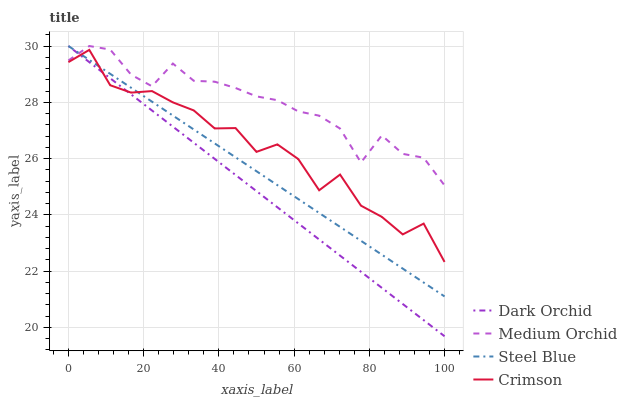Does Dark Orchid have the minimum area under the curve?
Answer yes or no. Yes. Does Medium Orchid have the maximum area under the curve?
Answer yes or no. Yes. Does Steel Blue have the minimum area under the curve?
Answer yes or no. No. Does Steel Blue have the maximum area under the curve?
Answer yes or no. No. Is Dark Orchid the smoothest?
Answer yes or no. Yes. Is Crimson the roughest?
Answer yes or no. Yes. Is Medium Orchid the smoothest?
Answer yes or no. No. Is Medium Orchid the roughest?
Answer yes or no. No. Does Dark Orchid have the lowest value?
Answer yes or no. Yes. Does Steel Blue have the lowest value?
Answer yes or no. No. Does Dark Orchid have the highest value?
Answer yes or no. Yes. Is Crimson less than Medium Orchid?
Answer yes or no. Yes. Is Medium Orchid greater than Crimson?
Answer yes or no. Yes. Does Steel Blue intersect Dark Orchid?
Answer yes or no. Yes. Is Steel Blue less than Dark Orchid?
Answer yes or no. No. Is Steel Blue greater than Dark Orchid?
Answer yes or no. No. Does Crimson intersect Medium Orchid?
Answer yes or no. No. 